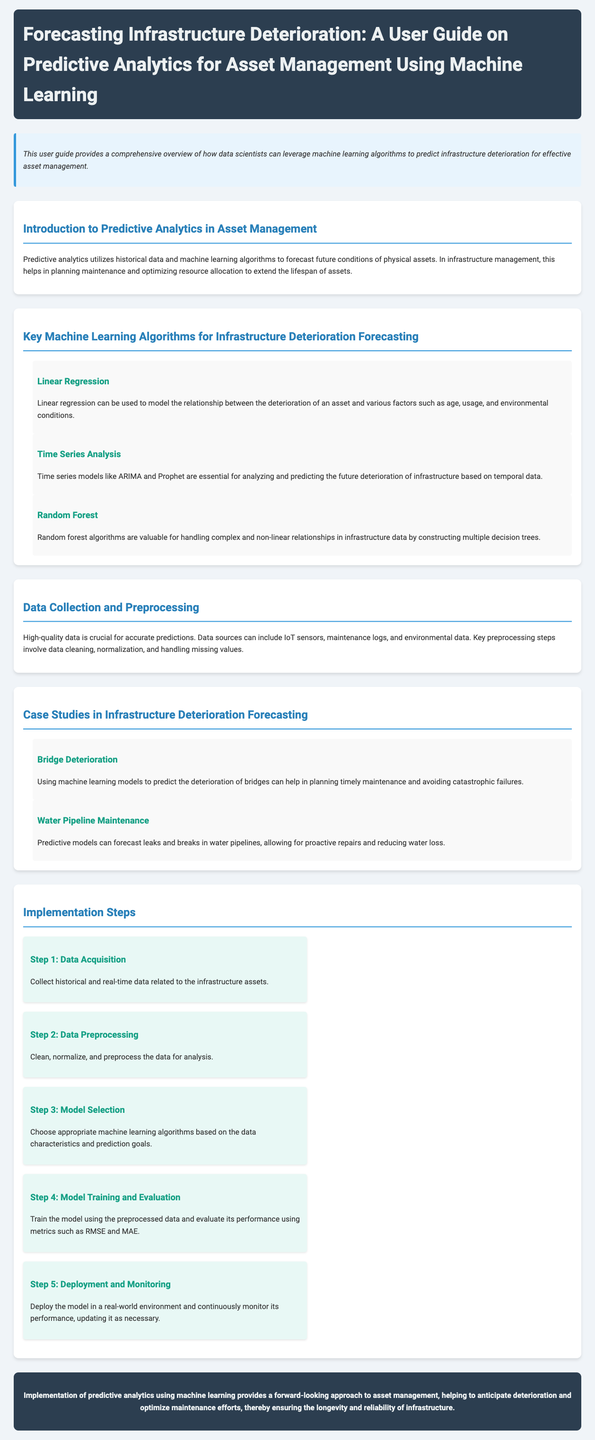What is the title of the user guide? The title of the user guide is specifically stated at the beginning of the document.
Answer: Forecasting Infrastructure Deterioration: A User Guide on Predictive Analytics for Asset Management Using Machine Learning What is the first key machine learning algorithm mentioned? The first algorithm discussed in the key machine learning algorithm section is noted for its simplicity and effectiveness.
Answer: Linear Regression How many steps are there in the implementation process? The document lists specific sequential steps for implementing predictive analytics in asset management.
Answer: 5 What type of data sources are mentioned for data collection? The document provides examples of sources for obtaining necessary data for predictions.
Answer: IoT sensors, maintenance logs, environmental data What is a benefit of predictive models for water pipeline maintenance? The document highlights a specific advantage of using predictive models in pipeline management that improves efficiency and prevents issues.
Answer: Proactive repairs What algorithm is used for analyzing temporal data? The document specifies an algorithm that is essential for forecasting based on time-dependent data.
Answer: Time Series Analysis Which infrastructure case study involves avoiding catastrophic failures? The specific case study in the document focuses on predicting deterioration to prevent severe incidents.
Answer: Bridge Deterioration What metric is mentioned for model evaluation? The document contains specific performance metrics to assess the effectiveness of the predictive models.
Answer: RMSE What is the overarching theme of the user guide? The introduction outlines the main focus and goal of the user guide related to asset management and predictive analytics.
Answer: Predictive analytics for asset management 